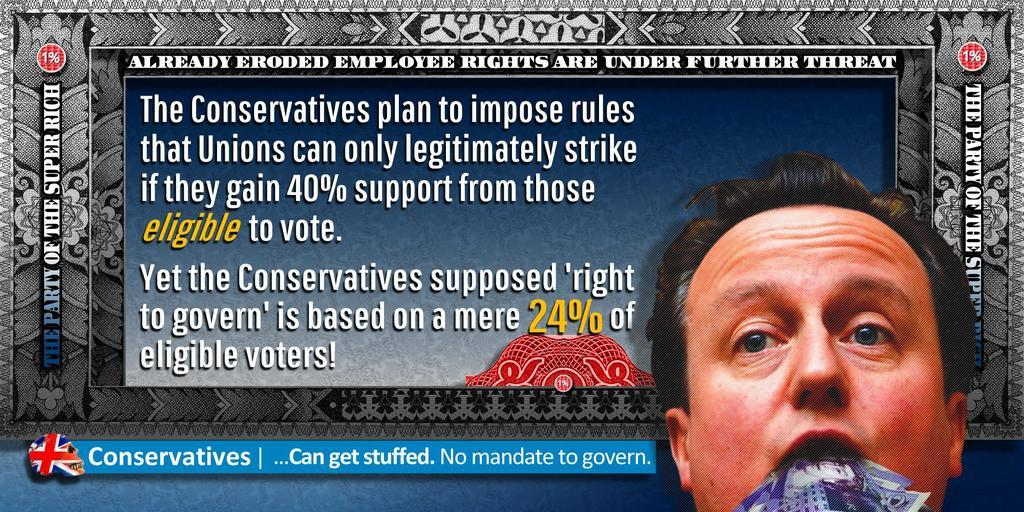What is present in the image that features a visual representation? There is a poster in the image. What is the main subject of the poster? There is a man depicted on the poster. What else can be seen on the poster besides the man? There is text written on the poster. Where is the maid located in the image? There is no maid present in the image. What type of store is depicted on the poster? The poster does not depict a store; it features a man and text. 